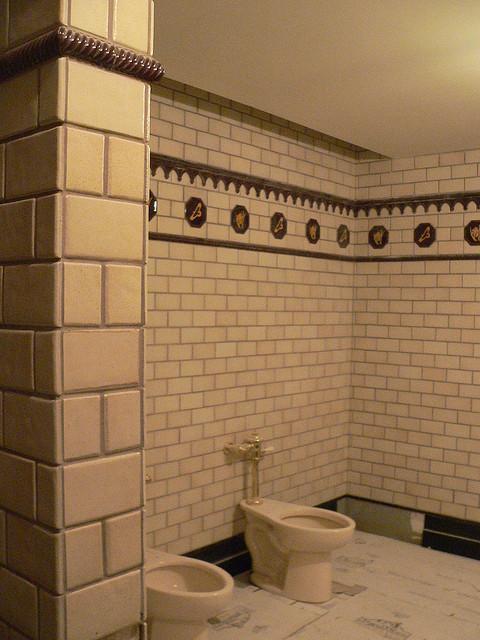How many toilets are there?
Give a very brief answer. 2. How many toilets can you see?
Give a very brief answer. 2. How many people are standing to the right of the bus?
Give a very brief answer. 0. 